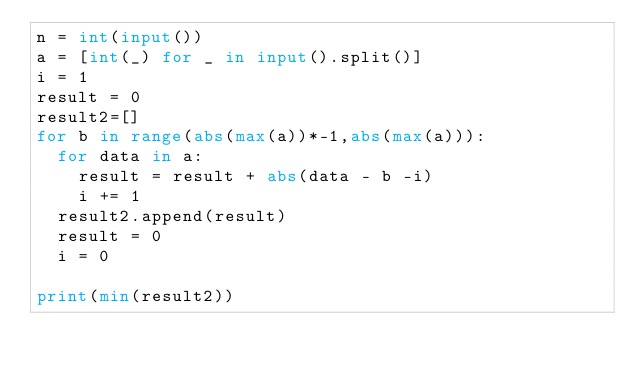Convert code to text. <code><loc_0><loc_0><loc_500><loc_500><_Python_>n = int(input())
a = [int(_) for _ in input().split()]
i = 1
result = 0
result2=[]
for b in range(abs(max(a))*-1,abs(max(a))):
  for data in a:
    result = result + abs(data - b -i)
    i += 1
  result2.append(result)
  result = 0
  i = 0

print(min(result2))</code> 